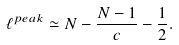<formula> <loc_0><loc_0><loc_500><loc_500>\ell ^ { p e a k } \simeq N - \frac { N - 1 } { c } - \frac { 1 } { 2 } .</formula> 